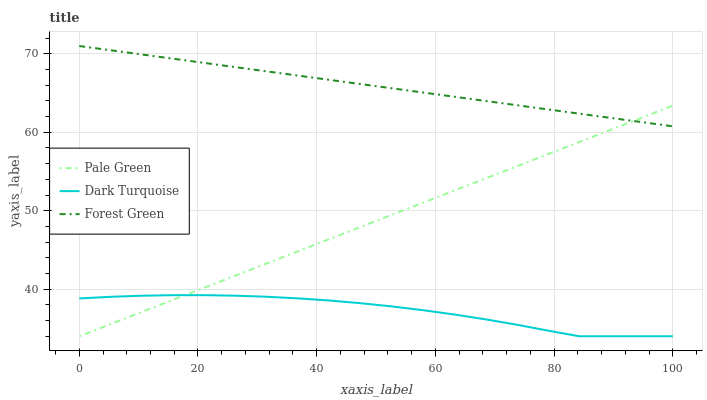Does Dark Turquoise have the minimum area under the curve?
Answer yes or no. Yes. Does Forest Green have the maximum area under the curve?
Answer yes or no. Yes. Does Pale Green have the minimum area under the curve?
Answer yes or no. No. Does Pale Green have the maximum area under the curve?
Answer yes or no. No. Is Pale Green the smoothest?
Answer yes or no. Yes. Is Dark Turquoise the roughest?
Answer yes or no. Yes. Is Forest Green the smoothest?
Answer yes or no. No. Is Forest Green the roughest?
Answer yes or no. No. Does Forest Green have the lowest value?
Answer yes or no. No. Does Forest Green have the highest value?
Answer yes or no. Yes. Does Pale Green have the highest value?
Answer yes or no. No. Is Dark Turquoise less than Forest Green?
Answer yes or no. Yes. Is Forest Green greater than Dark Turquoise?
Answer yes or no. Yes. Does Pale Green intersect Forest Green?
Answer yes or no. Yes. Is Pale Green less than Forest Green?
Answer yes or no. No. Is Pale Green greater than Forest Green?
Answer yes or no. No. Does Dark Turquoise intersect Forest Green?
Answer yes or no. No. 